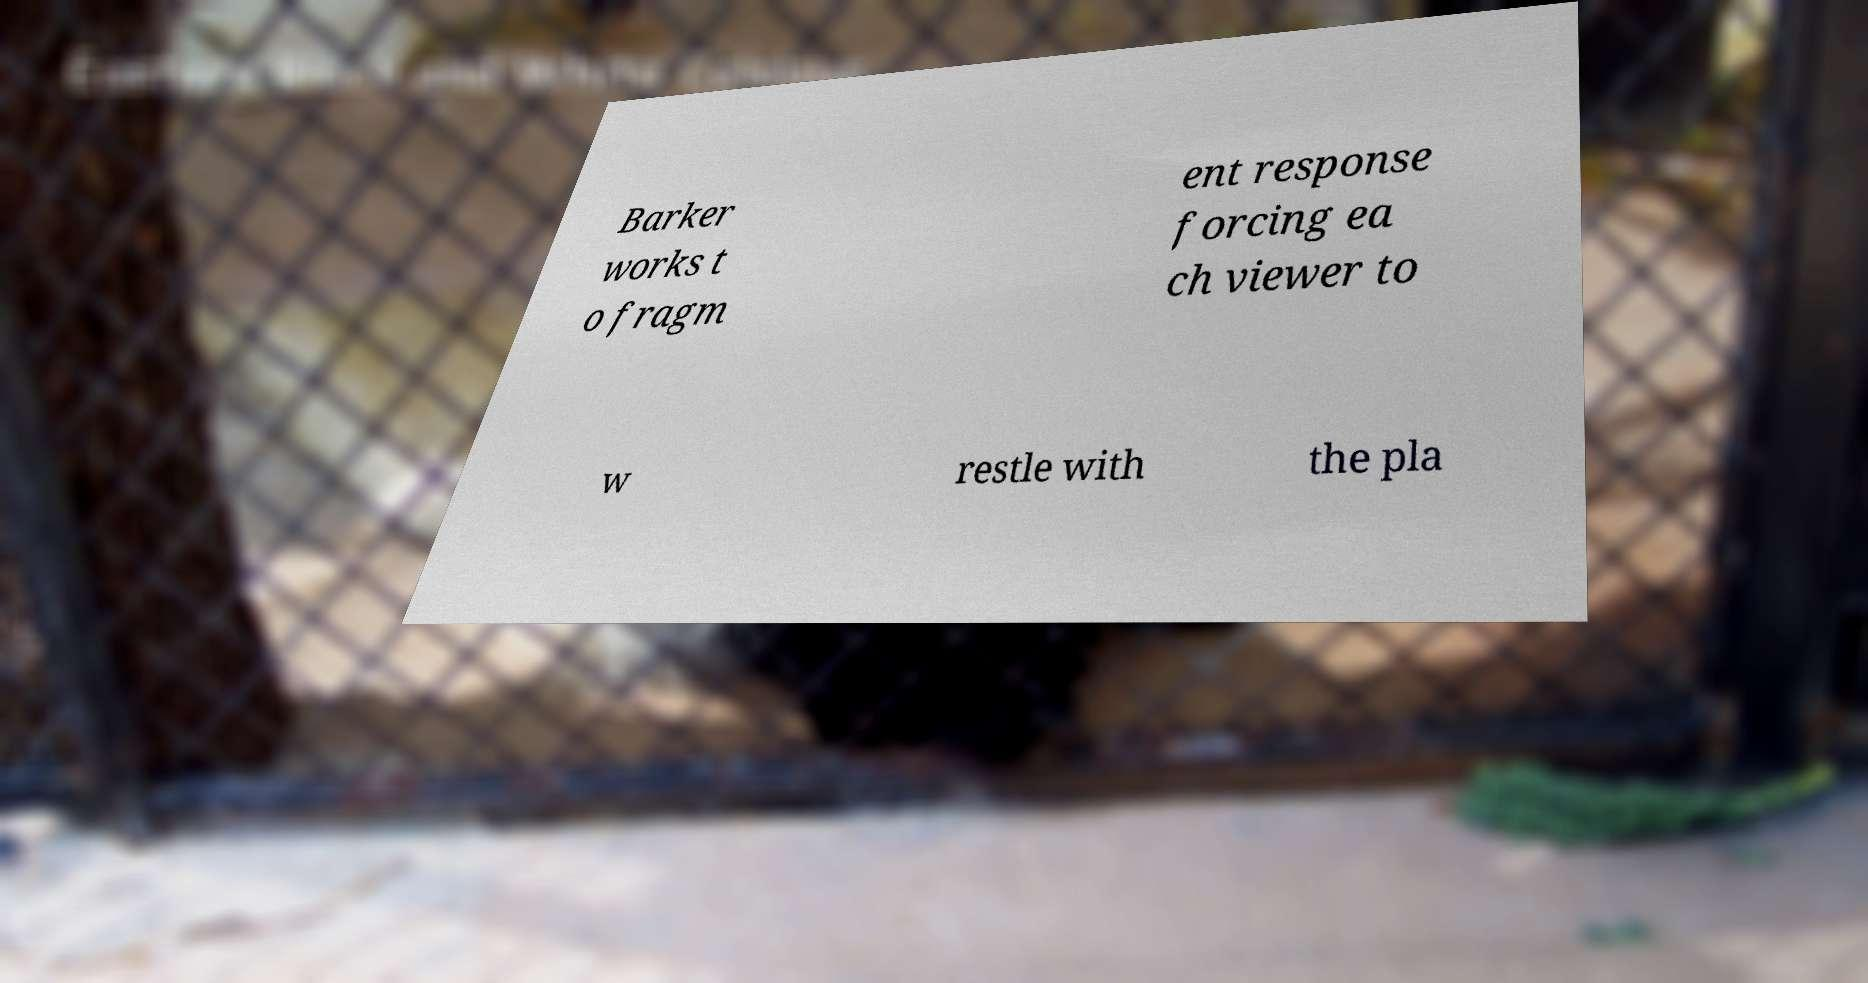What messages or text are displayed in this image? I need them in a readable, typed format. Barker works t o fragm ent response forcing ea ch viewer to w restle with the pla 